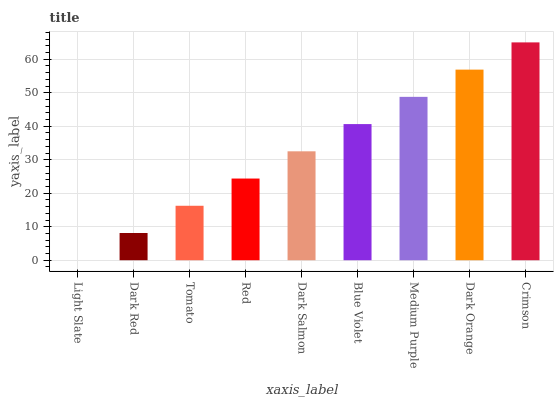Is Dark Red the minimum?
Answer yes or no. No. Is Dark Red the maximum?
Answer yes or no. No. Is Dark Red greater than Light Slate?
Answer yes or no. Yes. Is Light Slate less than Dark Red?
Answer yes or no. Yes. Is Light Slate greater than Dark Red?
Answer yes or no. No. Is Dark Red less than Light Slate?
Answer yes or no. No. Is Dark Salmon the high median?
Answer yes or no. Yes. Is Dark Salmon the low median?
Answer yes or no. Yes. Is Dark Orange the high median?
Answer yes or no. No. Is Tomato the low median?
Answer yes or no. No. 